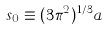<formula> <loc_0><loc_0><loc_500><loc_500>s _ { 0 } \equiv ( 3 \pi ^ { 2 } ) ^ { 1 / 3 } a</formula> 